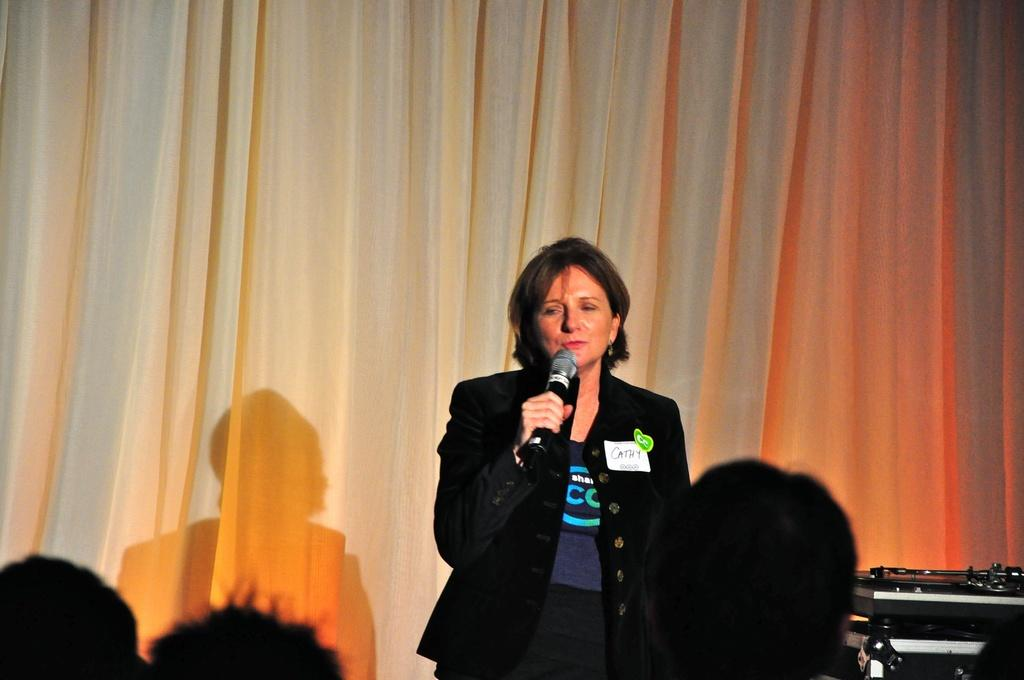Who is the main subject in the image? There is a woman in the image. What is the woman wearing? The woman is wearing a black coat. What is the woman holding in the image? The woman is holding a mic. What can be seen in the background of the image? There is a curtain visible in the image. Can you describe the people in the image? The heads of some people are visible in the image. What type of locket is the woman wearing in the image? There is no locket visible in the image; the woman is wearing a black coat. How many seats are present in the image? There is no mention of seats in the image; it features a woman holding a mic and a curtain in the background. 